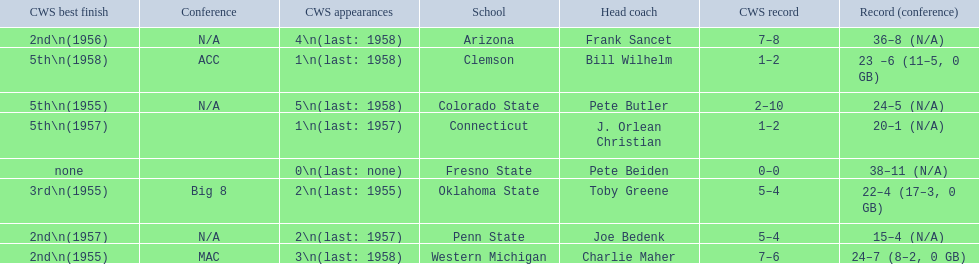What was the least amount of wins recorded by the losingest team? 15–4 (N/A). Which team held this record? Penn State. 